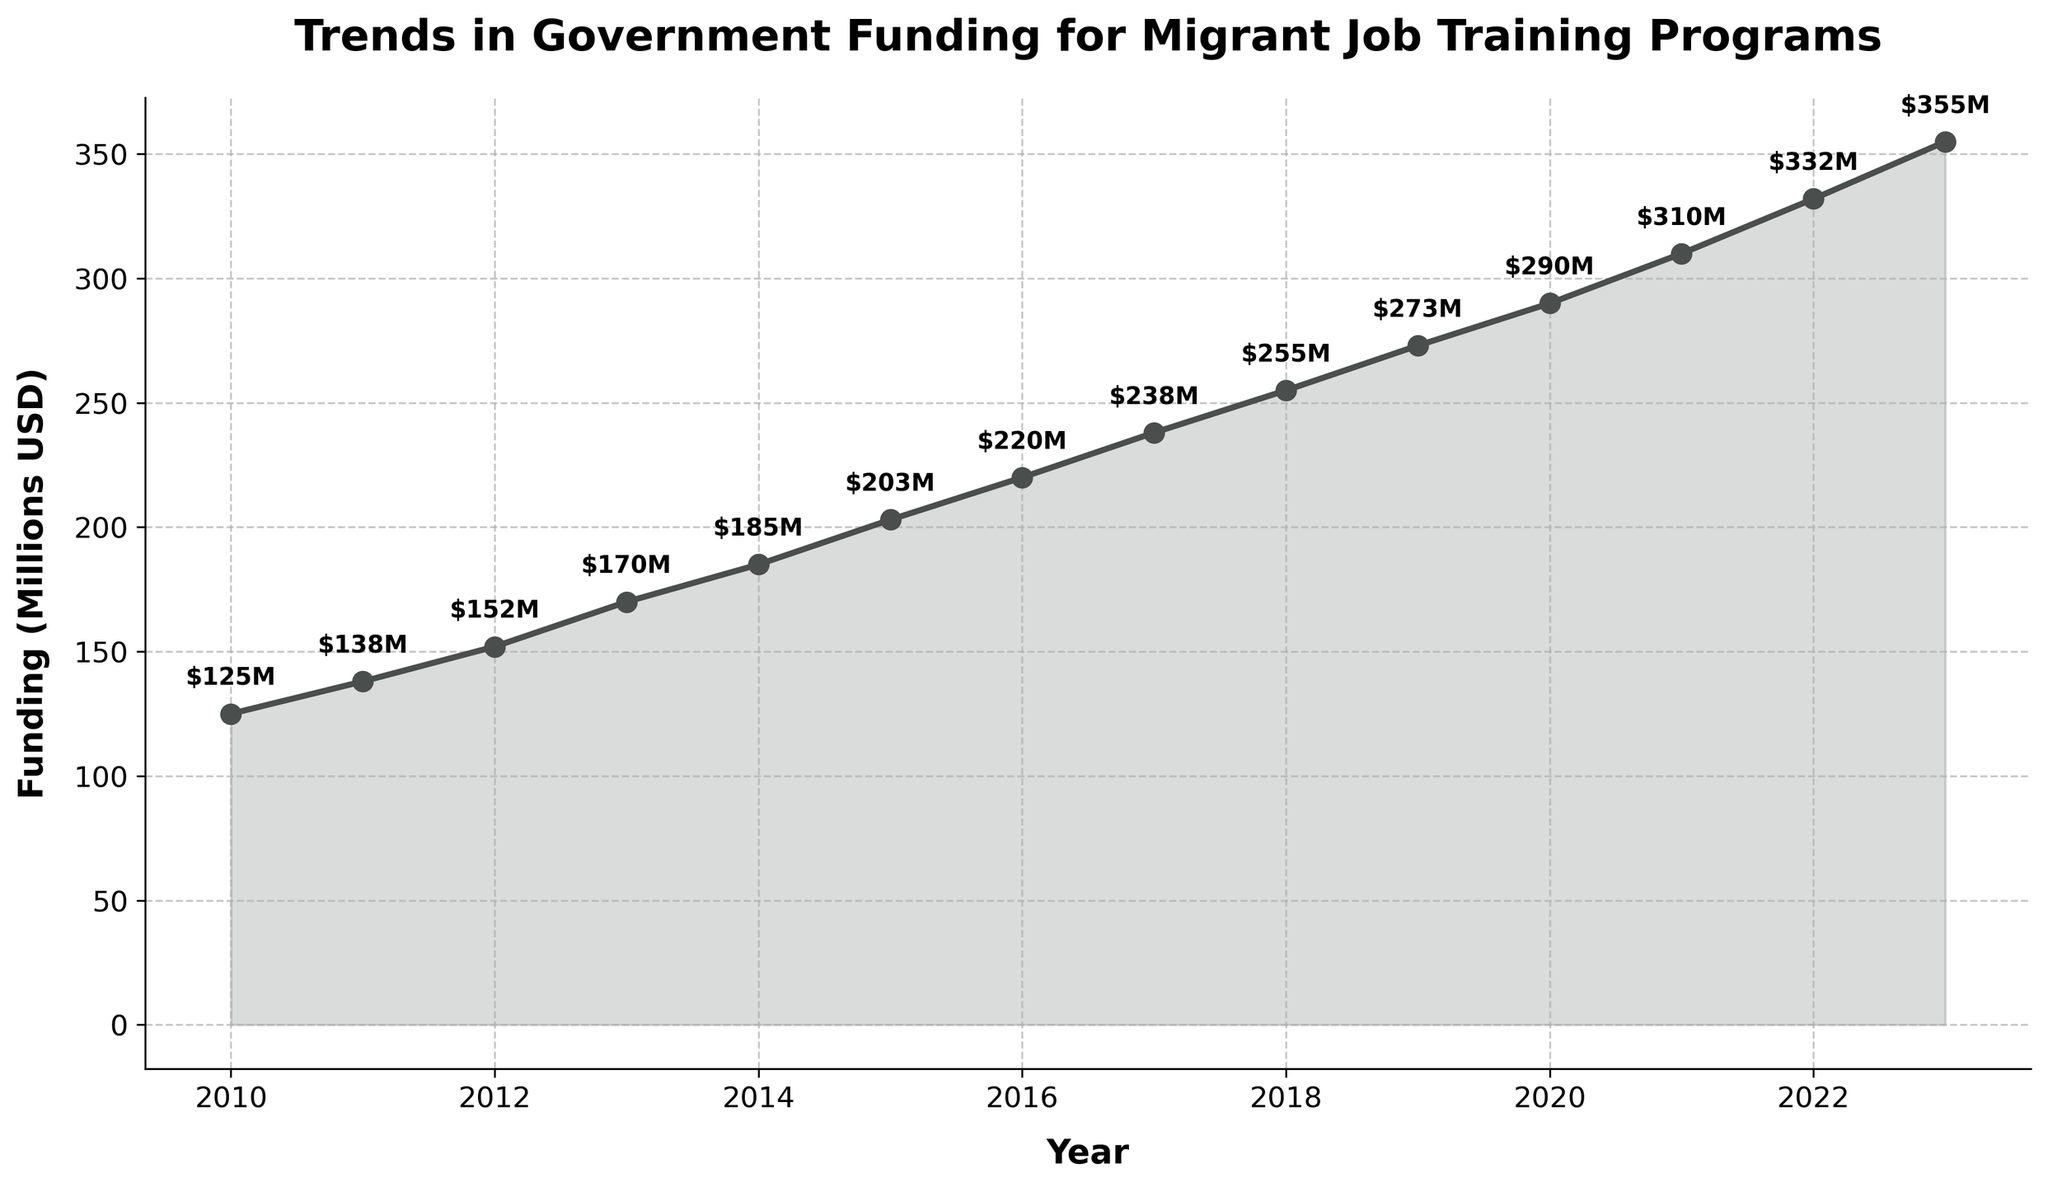What is the total funding in millions for the year 2023? Look for the data point corresponding to the year 2023 in the figure. The funding in that year is $355M.
Answer: $355M By how much did the funding increase from 2010 to 2023? To find the increase, subtract the funding in 2010 from the funding in 2023. This is $355M - $125M = $230M.
Answer: $230M What’s the average annual funding from 2010 to 2023? Add all the funding values from 2010 to 2023, then divide by the number of years (14). The sum of the values is $3611M, so the average is $3611M / 14 ≈ $258M.
Answer: $258M How does the funding in 2022 compare to the funding in 2018? Compare the two values directly: 2022 funding is $332M, and 2018 funding is $255M. Since $332M > $255M, the funding in 2022 is higher.
Answer: 2022 > 2018 During which years did the funding surpass the $300M mark? Look for the data points where the funding is greater than $300M. These years are 2021, 2022, and 2023.
Answer: 2021, 2022, 2023 Which year had the smallest increase in funding compared to the previous year? Calculate the year-to-year differences in funding and identify the smallest difference. The smallest increase from year to year is from 2019 to 2020, which is $290M - $273M = $17M.
Answer: 2019 to 2020 What is the median funding over the years 2010 to 2023? Arrange the funding values in ascending order and find the middle value. The median of the 14 values (mid values are the 7th and 8th values) which are $220M (2016) and $238M (2017) are (220 + 238) / 2 = $229M.
Answer: $229M Which year showed the highest year-over-year growth in funding? Calculate the growth for each year and find the maximum. The highest growth is from 2011 to 2012, where the difference is $152M - $138M = $14M.
Answer: 2011 to 2012 How has the trend in funding changed over the years from 2010 to 2023 visually? Observe the steepness of the line and the increasing trend in the plot. The funding shows a consistent upward trend with slight variations in the slope each year.
Answer: Upward trend 